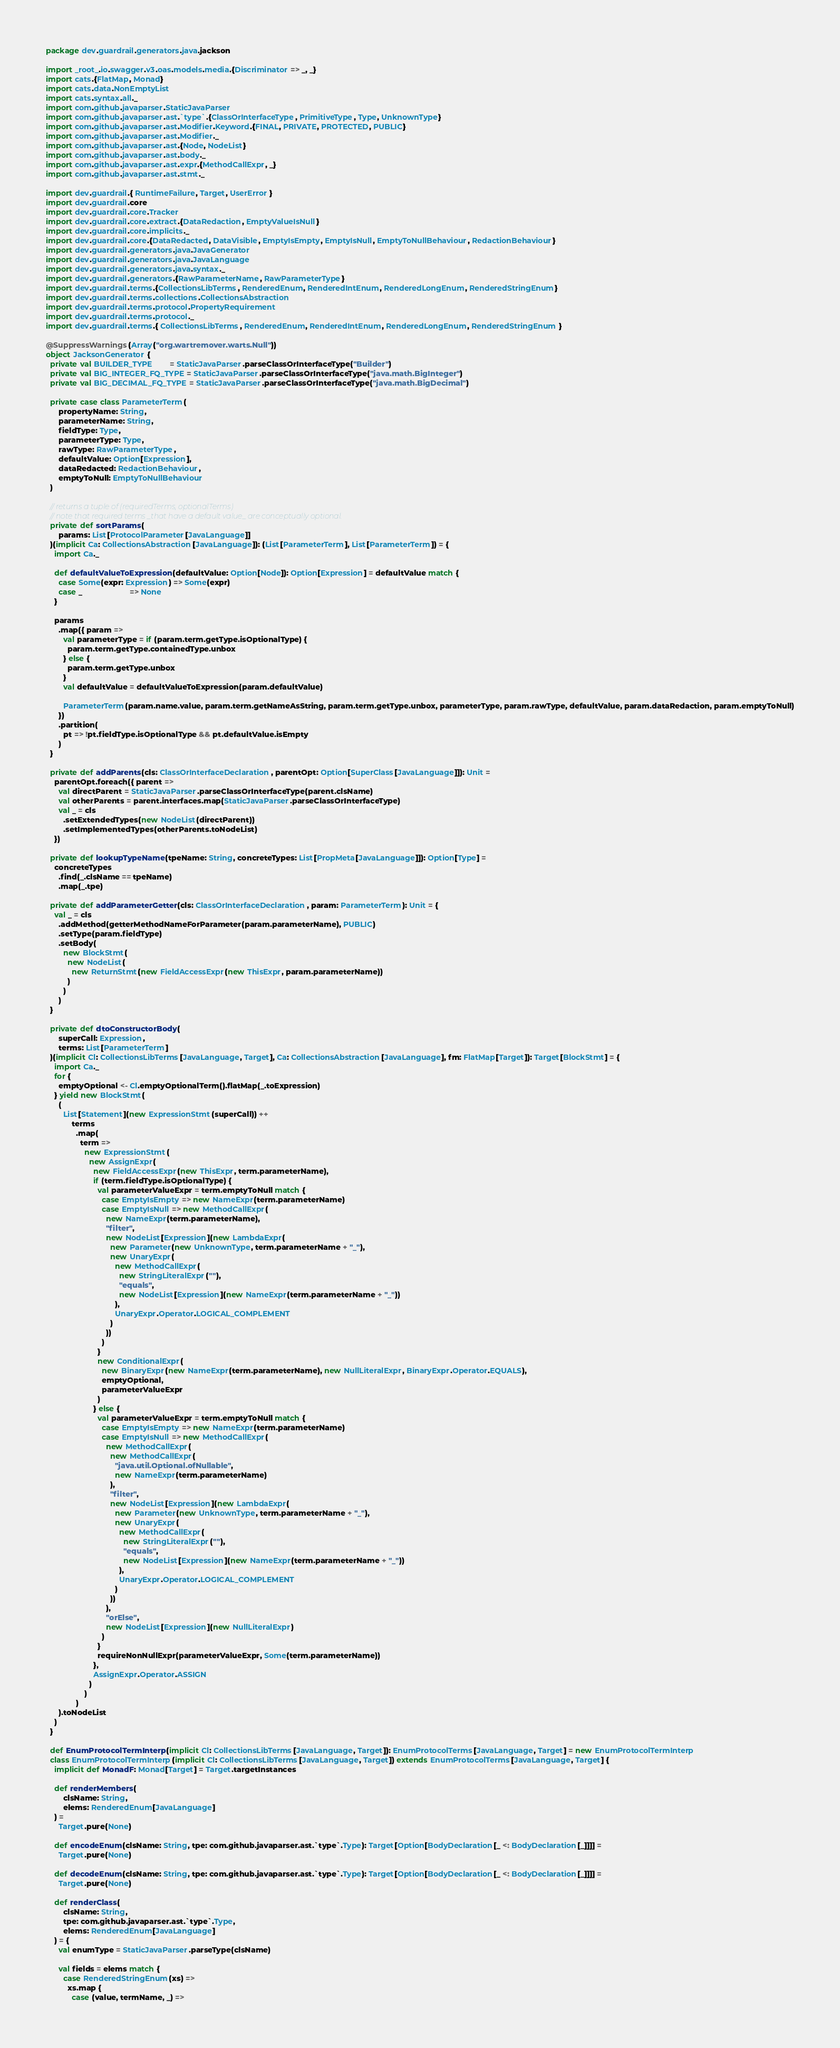Convert code to text. <code><loc_0><loc_0><loc_500><loc_500><_Scala_>package dev.guardrail.generators.java.jackson

import _root_.io.swagger.v3.oas.models.media.{Discriminator => _, _}
import cats.{FlatMap, Monad}
import cats.data.NonEmptyList
import cats.syntax.all._
import com.github.javaparser.StaticJavaParser
import com.github.javaparser.ast.`type`.{ClassOrInterfaceType, PrimitiveType, Type, UnknownType}
import com.github.javaparser.ast.Modifier.Keyword.{FINAL, PRIVATE, PROTECTED, PUBLIC}
import com.github.javaparser.ast.Modifier._
import com.github.javaparser.ast.{Node, NodeList}
import com.github.javaparser.ast.body._
import com.github.javaparser.ast.expr.{MethodCallExpr, _}
import com.github.javaparser.ast.stmt._

import dev.guardrail.{ RuntimeFailure, Target, UserError }
import dev.guardrail.core
import dev.guardrail.core.Tracker
import dev.guardrail.core.extract.{DataRedaction, EmptyValueIsNull}
import dev.guardrail.core.implicits._
import dev.guardrail.core.{DataRedacted, DataVisible, EmptyIsEmpty, EmptyIsNull, EmptyToNullBehaviour, RedactionBehaviour}
import dev.guardrail.generators.java.JavaGenerator
import dev.guardrail.generators.java.JavaLanguage
import dev.guardrail.generators.java.syntax._
import dev.guardrail.generators.{RawParameterName, RawParameterType}
import dev.guardrail.terms.{CollectionsLibTerms, RenderedEnum, RenderedIntEnum, RenderedLongEnum, RenderedStringEnum}
import dev.guardrail.terms.collections.CollectionsAbstraction
import dev.guardrail.terms.protocol.PropertyRequirement
import dev.guardrail.terms.protocol._
import dev.guardrail.terms.{ CollectionsLibTerms, RenderedEnum, RenderedIntEnum, RenderedLongEnum, RenderedStringEnum }

@SuppressWarnings(Array("org.wartremover.warts.Null"))
object JacksonGenerator {
  private val BUILDER_TYPE        = StaticJavaParser.parseClassOrInterfaceType("Builder")
  private val BIG_INTEGER_FQ_TYPE = StaticJavaParser.parseClassOrInterfaceType("java.math.BigInteger")
  private val BIG_DECIMAL_FQ_TYPE = StaticJavaParser.parseClassOrInterfaceType("java.math.BigDecimal")

  private case class ParameterTerm(
      propertyName: String,
      parameterName: String,
      fieldType: Type,
      parameterType: Type,
      rawType: RawParameterType,
      defaultValue: Option[Expression],
      dataRedacted: RedactionBehaviour,
      emptyToNull: EmptyToNullBehaviour
  )

  // returns a tuple of (requiredTerms, optionalTerms)
  // note that required terms _that have a default value_ are conceptually optional.
  private def sortParams(
      params: List[ProtocolParameter[JavaLanguage]]
  )(implicit Ca: CollectionsAbstraction[JavaLanguage]): (List[ParameterTerm], List[ParameterTerm]) = {
    import Ca._

    def defaultValueToExpression(defaultValue: Option[Node]): Option[Expression] = defaultValue match {
      case Some(expr: Expression) => Some(expr)
      case _                      => None
    }

    params
      .map({ param =>
        val parameterType = if (param.term.getType.isOptionalType) {
          param.term.getType.containedType.unbox
        } else {
          param.term.getType.unbox
        }
        val defaultValue = defaultValueToExpression(param.defaultValue)

        ParameterTerm(param.name.value, param.term.getNameAsString, param.term.getType.unbox, parameterType, param.rawType, defaultValue, param.dataRedaction, param.emptyToNull)
      })
      .partition(
        pt => !pt.fieldType.isOptionalType && pt.defaultValue.isEmpty
      )
  }

  private def addParents(cls: ClassOrInterfaceDeclaration, parentOpt: Option[SuperClass[JavaLanguage]]): Unit =
    parentOpt.foreach({ parent =>
      val directParent = StaticJavaParser.parseClassOrInterfaceType(parent.clsName)
      val otherParents = parent.interfaces.map(StaticJavaParser.parseClassOrInterfaceType)
      val _ = cls
        .setExtendedTypes(new NodeList(directParent))
        .setImplementedTypes(otherParents.toNodeList)
    })

  private def lookupTypeName(tpeName: String, concreteTypes: List[PropMeta[JavaLanguage]]): Option[Type] =
    concreteTypes
      .find(_.clsName == tpeName)
      .map(_.tpe)

  private def addParameterGetter(cls: ClassOrInterfaceDeclaration, param: ParameterTerm): Unit = {
    val _ = cls
      .addMethod(getterMethodNameForParameter(param.parameterName), PUBLIC)
      .setType(param.fieldType)
      .setBody(
        new BlockStmt(
          new NodeList(
            new ReturnStmt(new FieldAccessExpr(new ThisExpr, param.parameterName))
          )
        )
      )
  }

  private def dtoConstructorBody(
      superCall: Expression,
      terms: List[ParameterTerm]
  )(implicit Cl: CollectionsLibTerms[JavaLanguage, Target], Ca: CollectionsAbstraction[JavaLanguage], fm: FlatMap[Target]): Target[BlockStmt] = {
    import Ca._
    for {
      emptyOptional <- Cl.emptyOptionalTerm().flatMap(_.toExpression)
    } yield new BlockStmt(
      (
        List[Statement](new ExpressionStmt(superCall)) ++
            terms
              .map(
                term =>
                  new ExpressionStmt(
                    new AssignExpr(
                      new FieldAccessExpr(new ThisExpr, term.parameterName),
                      if (term.fieldType.isOptionalType) {
                        val parameterValueExpr = term.emptyToNull match {
                          case EmptyIsEmpty => new NameExpr(term.parameterName)
                          case EmptyIsNull => new MethodCallExpr(
                            new NameExpr(term.parameterName),
                            "filter",
                            new NodeList[Expression](new LambdaExpr(
                              new Parameter(new UnknownType, term.parameterName + "_"),
                              new UnaryExpr(
                                new MethodCallExpr(
                                  new StringLiteralExpr(""),
                                  "equals",
                                  new NodeList[Expression](new NameExpr(term.parameterName + "_"))
                                ),
                                UnaryExpr.Operator.LOGICAL_COMPLEMENT
                              )
                            ))
                          )
                        }
                        new ConditionalExpr(
                          new BinaryExpr(new NameExpr(term.parameterName), new NullLiteralExpr, BinaryExpr.Operator.EQUALS),
                          emptyOptional,
                          parameterValueExpr
                        )
                      } else {
                        val parameterValueExpr = term.emptyToNull match {
                          case EmptyIsEmpty => new NameExpr(term.parameterName)
                          case EmptyIsNull => new MethodCallExpr(
                            new MethodCallExpr(
                              new MethodCallExpr(
                                "java.util.Optional.ofNullable",
                                new NameExpr(term.parameterName)
                              ),
                              "filter",
                              new NodeList[Expression](new LambdaExpr(
                                new Parameter(new UnknownType, term.parameterName + "_"),
                                new UnaryExpr(
                                  new MethodCallExpr(
                                    new StringLiteralExpr(""),
                                    "equals",
                                    new NodeList[Expression](new NameExpr(term.parameterName + "_"))
                                  ),
                                  UnaryExpr.Operator.LOGICAL_COMPLEMENT
                                )
                              ))
                            ),
                            "orElse",
                            new NodeList[Expression](new NullLiteralExpr)
                          )
                        }
                        requireNonNullExpr(parameterValueExpr, Some(term.parameterName))
                      },
                      AssignExpr.Operator.ASSIGN
                    )
                  )
              )
      ).toNodeList
    )
  }

  def EnumProtocolTermInterp(implicit Cl: CollectionsLibTerms[JavaLanguage, Target]): EnumProtocolTerms[JavaLanguage, Target] = new EnumProtocolTermInterp
  class EnumProtocolTermInterp(implicit Cl: CollectionsLibTerms[JavaLanguage, Target]) extends EnumProtocolTerms[JavaLanguage, Target] {
    implicit def MonadF: Monad[Target] = Target.targetInstances

    def renderMembers(
        clsName: String,
        elems: RenderedEnum[JavaLanguage]
    ) =
      Target.pure(None)

    def encodeEnum(clsName: String, tpe: com.github.javaparser.ast.`type`.Type): Target[Option[BodyDeclaration[_ <: BodyDeclaration[_]]]] =
      Target.pure(None)

    def decodeEnum(clsName: String, tpe: com.github.javaparser.ast.`type`.Type): Target[Option[BodyDeclaration[_ <: BodyDeclaration[_]]]] =
      Target.pure(None)

    def renderClass(
        clsName: String,
        tpe: com.github.javaparser.ast.`type`.Type,
        elems: RenderedEnum[JavaLanguage]
    ) = {
      val enumType = StaticJavaParser.parseType(clsName)

      val fields = elems match {
        case RenderedStringEnum(xs) =>
          xs.map {
            case (value, termName, _) =></code> 